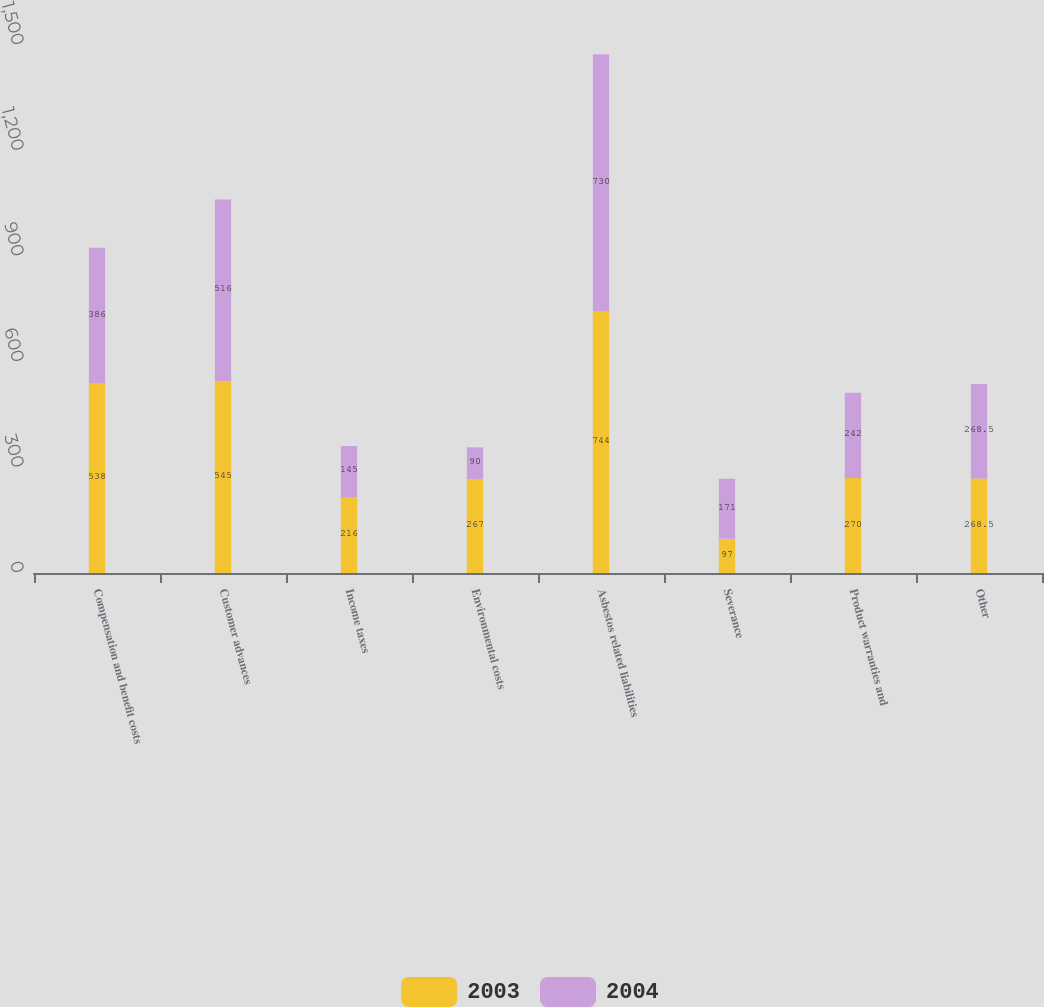Convert chart to OTSL. <chart><loc_0><loc_0><loc_500><loc_500><stacked_bar_chart><ecel><fcel>Compensation and benefit costs<fcel>Customer advances<fcel>Income taxes<fcel>Environmental costs<fcel>Asbestos related liabilities<fcel>Severance<fcel>Product warranties and<fcel>Other<nl><fcel>2003<fcel>538<fcel>545<fcel>216<fcel>267<fcel>744<fcel>97<fcel>270<fcel>268.5<nl><fcel>2004<fcel>386<fcel>516<fcel>145<fcel>90<fcel>730<fcel>171<fcel>242<fcel>268.5<nl></chart> 